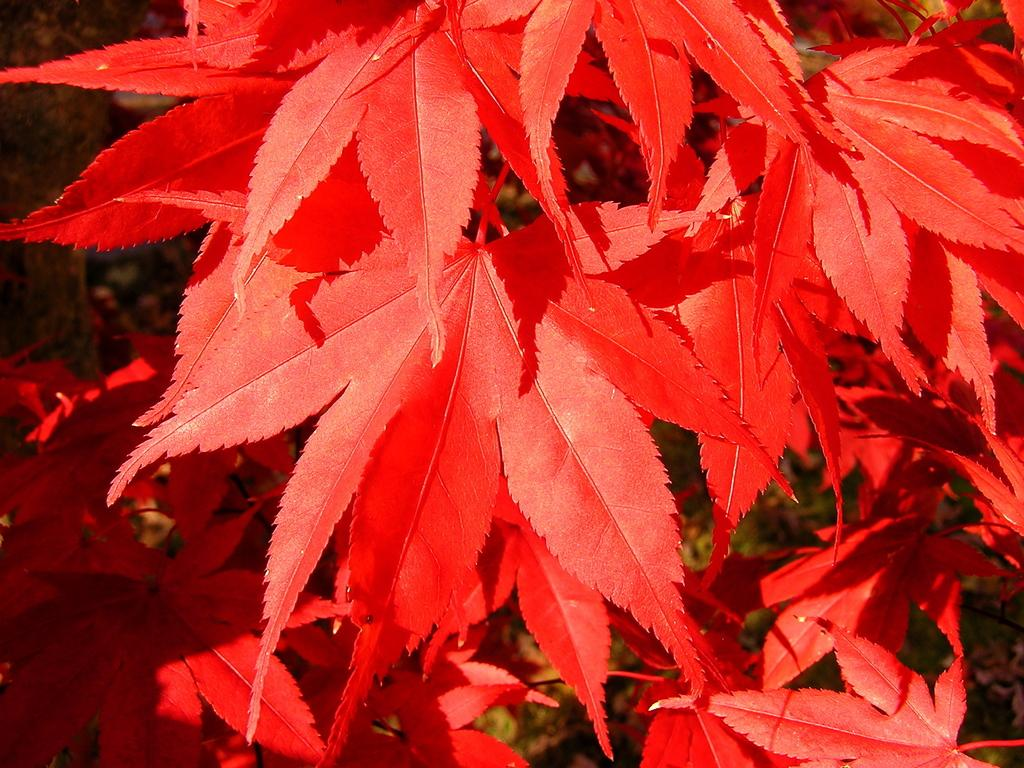What type of vegetation is present in the image? There are red color leaves in the image. Can you describe the background of the image? The background of the image is blurred. How many children are visible in the image? There are no children present in the image. What type of coil is wrapped around the leaves in the image? There is no coil present in the image; it only features red color leaves and a blurred background. 